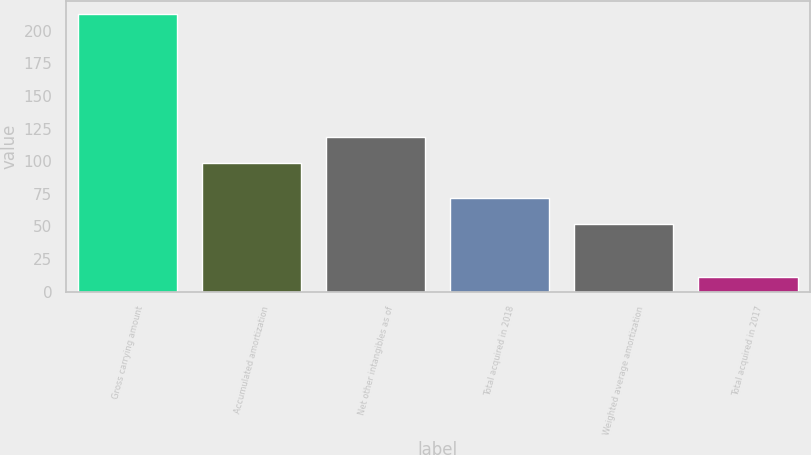Convert chart to OTSL. <chart><loc_0><loc_0><loc_500><loc_500><bar_chart><fcel>Gross carrying amount<fcel>Accumulated amortization<fcel>Net other intangibles as of<fcel>Total acquired in 2018<fcel>Weighted average amortization<fcel>Total acquired in 2017<nl><fcel>212.5<fcel>98.8<fcel>118.91<fcel>71.73<fcel>51.62<fcel>11.4<nl></chart> 